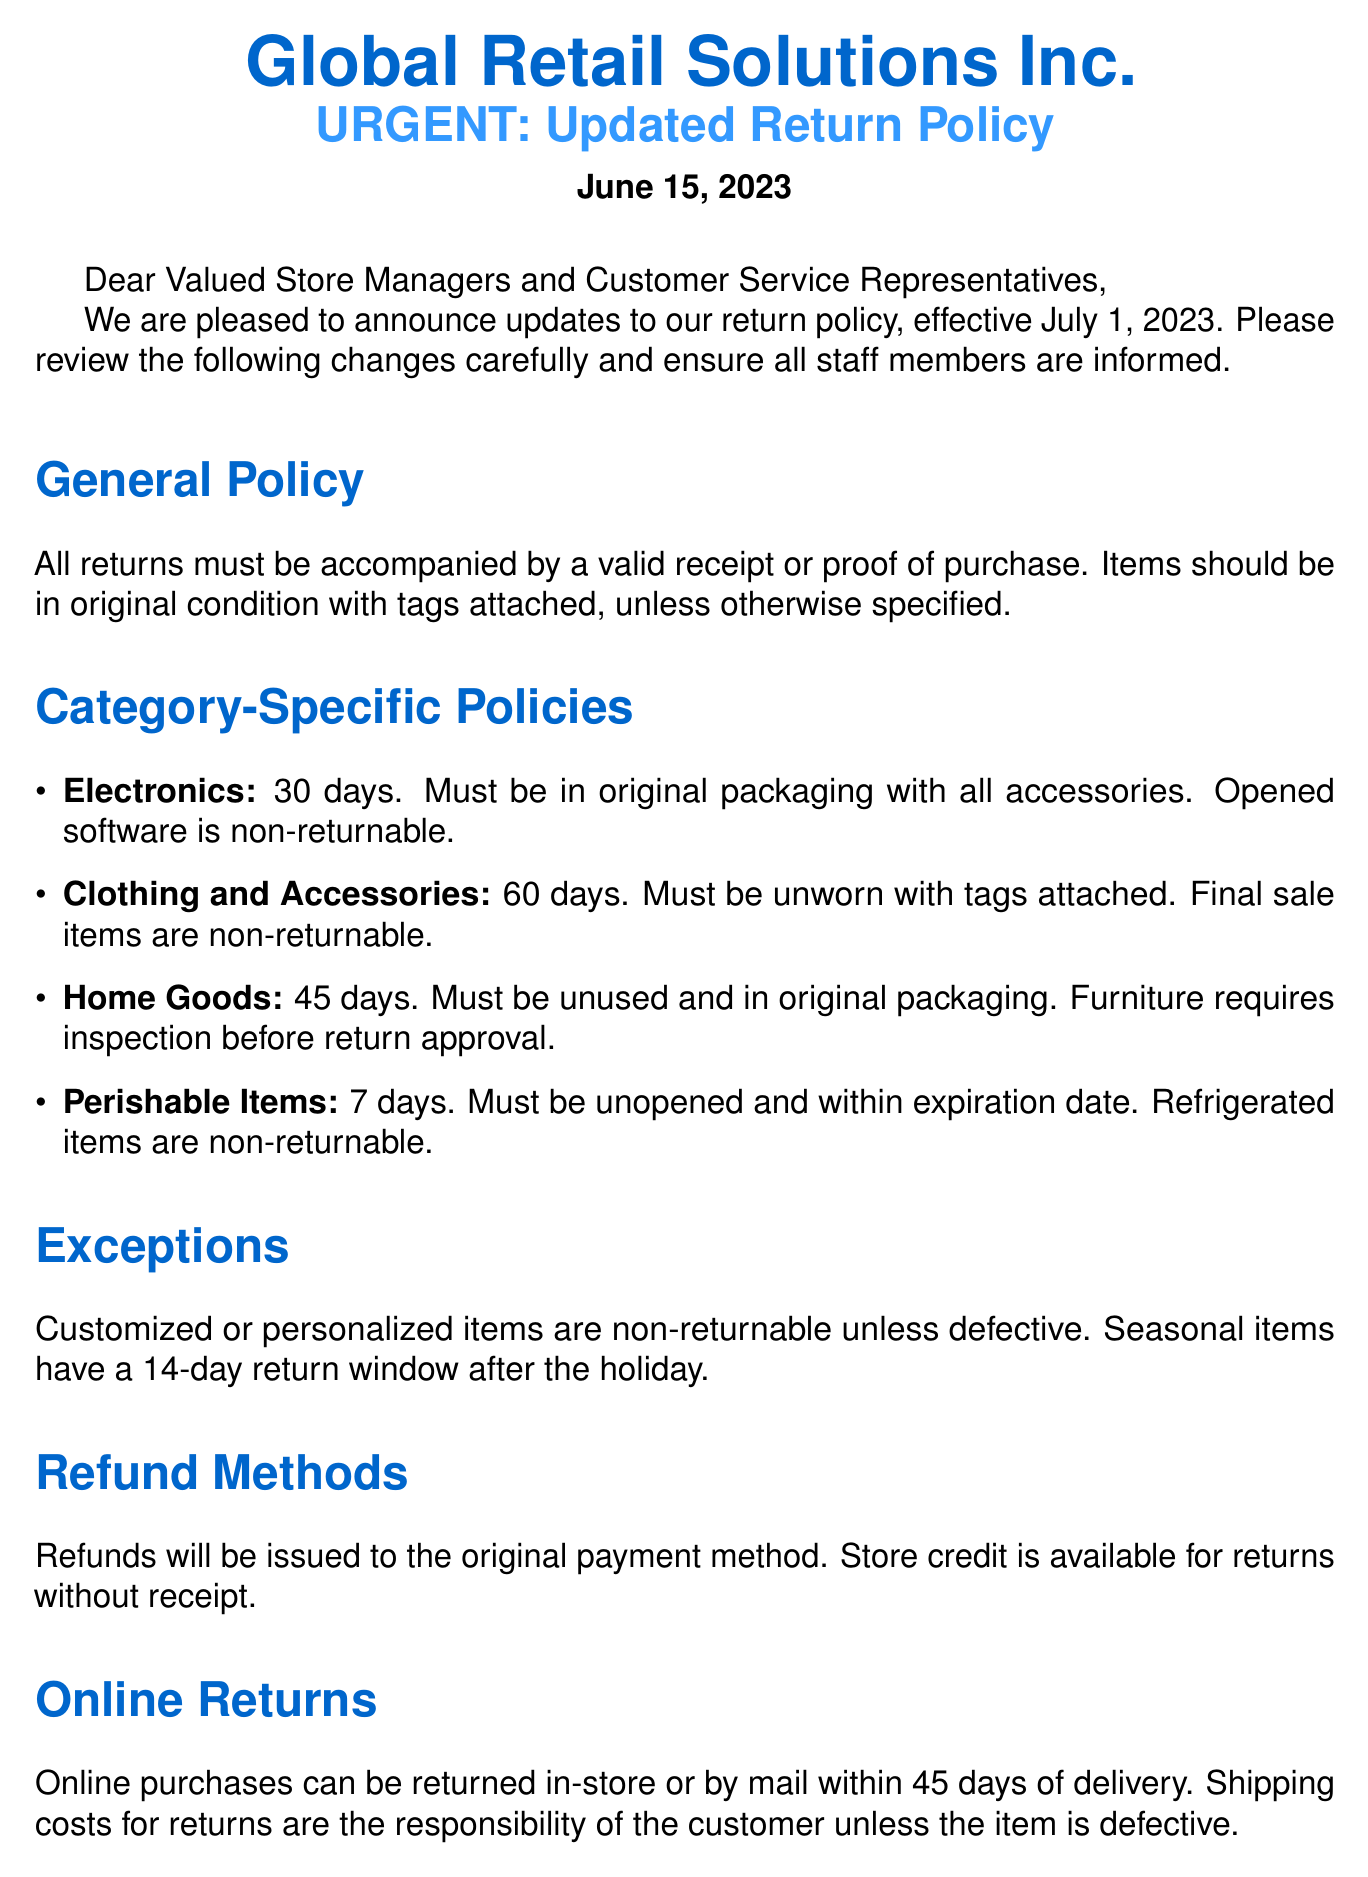what is the effective date of the updated return policy? The effective date of the updated return policy is mentioned in the document as July 1, 2023.
Answer: July 1, 2023 how many days do customers have to return electronics? The document specifies that electronics can be returned within 30 days.
Answer: 30 days which item category has the shortest return window? The return window for perishable items is mentioned to be the shortest among all categories.
Answer: Perishable Items are final sale items returnable? The document explicitly states that final sale items are non-returnable.
Answer: Non-returnable what refund method is available for returns without a receipt? The document indicates that store credit is available for returns made without a receipt.
Answer: Store credit how long do clothing and accessories have for returns? The policy states that clothing and accessories must be returned within 60 days.
Answer: 60 days who is the Customer Service Director? The document lists Emily Thompson as the Customer Service Director.
Answer: Emily Thompson what should customers do if they want to return an online purchase? Customers can return online purchases in-store or by mail within a specified time frame according to the policy.
Answer: In-store or by mail how are refunds issued? The document states that refunds will be issued to the original payment method.
Answer: Original payment method 